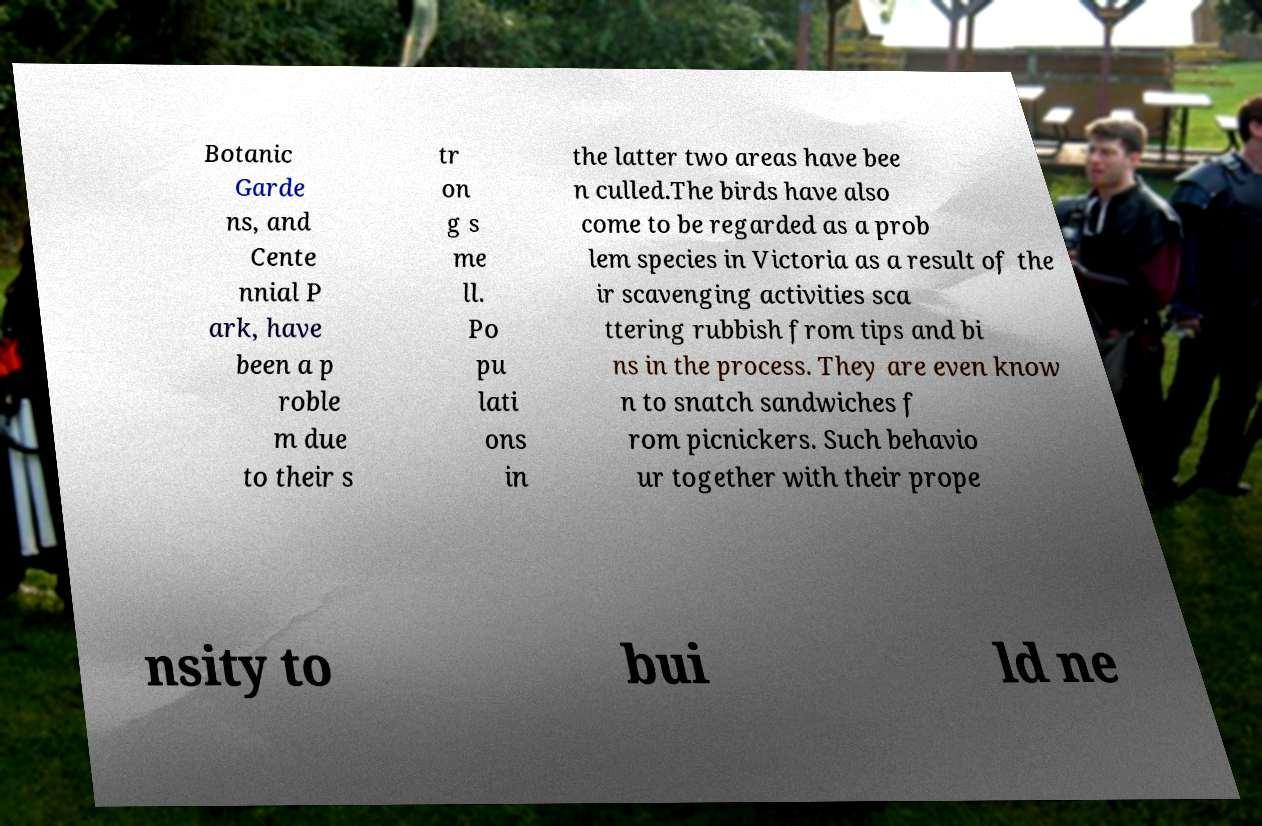Please identify and transcribe the text found in this image. Botanic Garde ns, and Cente nnial P ark, have been a p roble m due to their s tr on g s me ll. Po pu lati ons in the latter two areas have bee n culled.The birds have also come to be regarded as a prob lem species in Victoria as a result of the ir scavenging activities sca ttering rubbish from tips and bi ns in the process. They are even know n to snatch sandwiches f rom picnickers. Such behavio ur together with their prope nsity to bui ld ne 